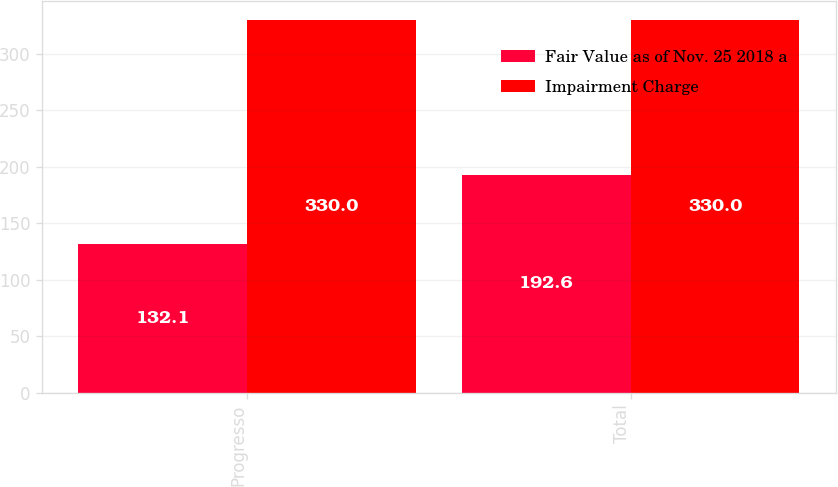Convert chart to OTSL. <chart><loc_0><loc_0><loc_500><loc_500><stacked_bar_chart><ecel><fcel>Progresso<fcel>Total<nl><fcel>Fair Value as of Nov. 25 2018 a<fcel>132.1<fcel>192.6<nl><fcel>Impairment Charge<fcel>330<fcel>330<nl></chart> 